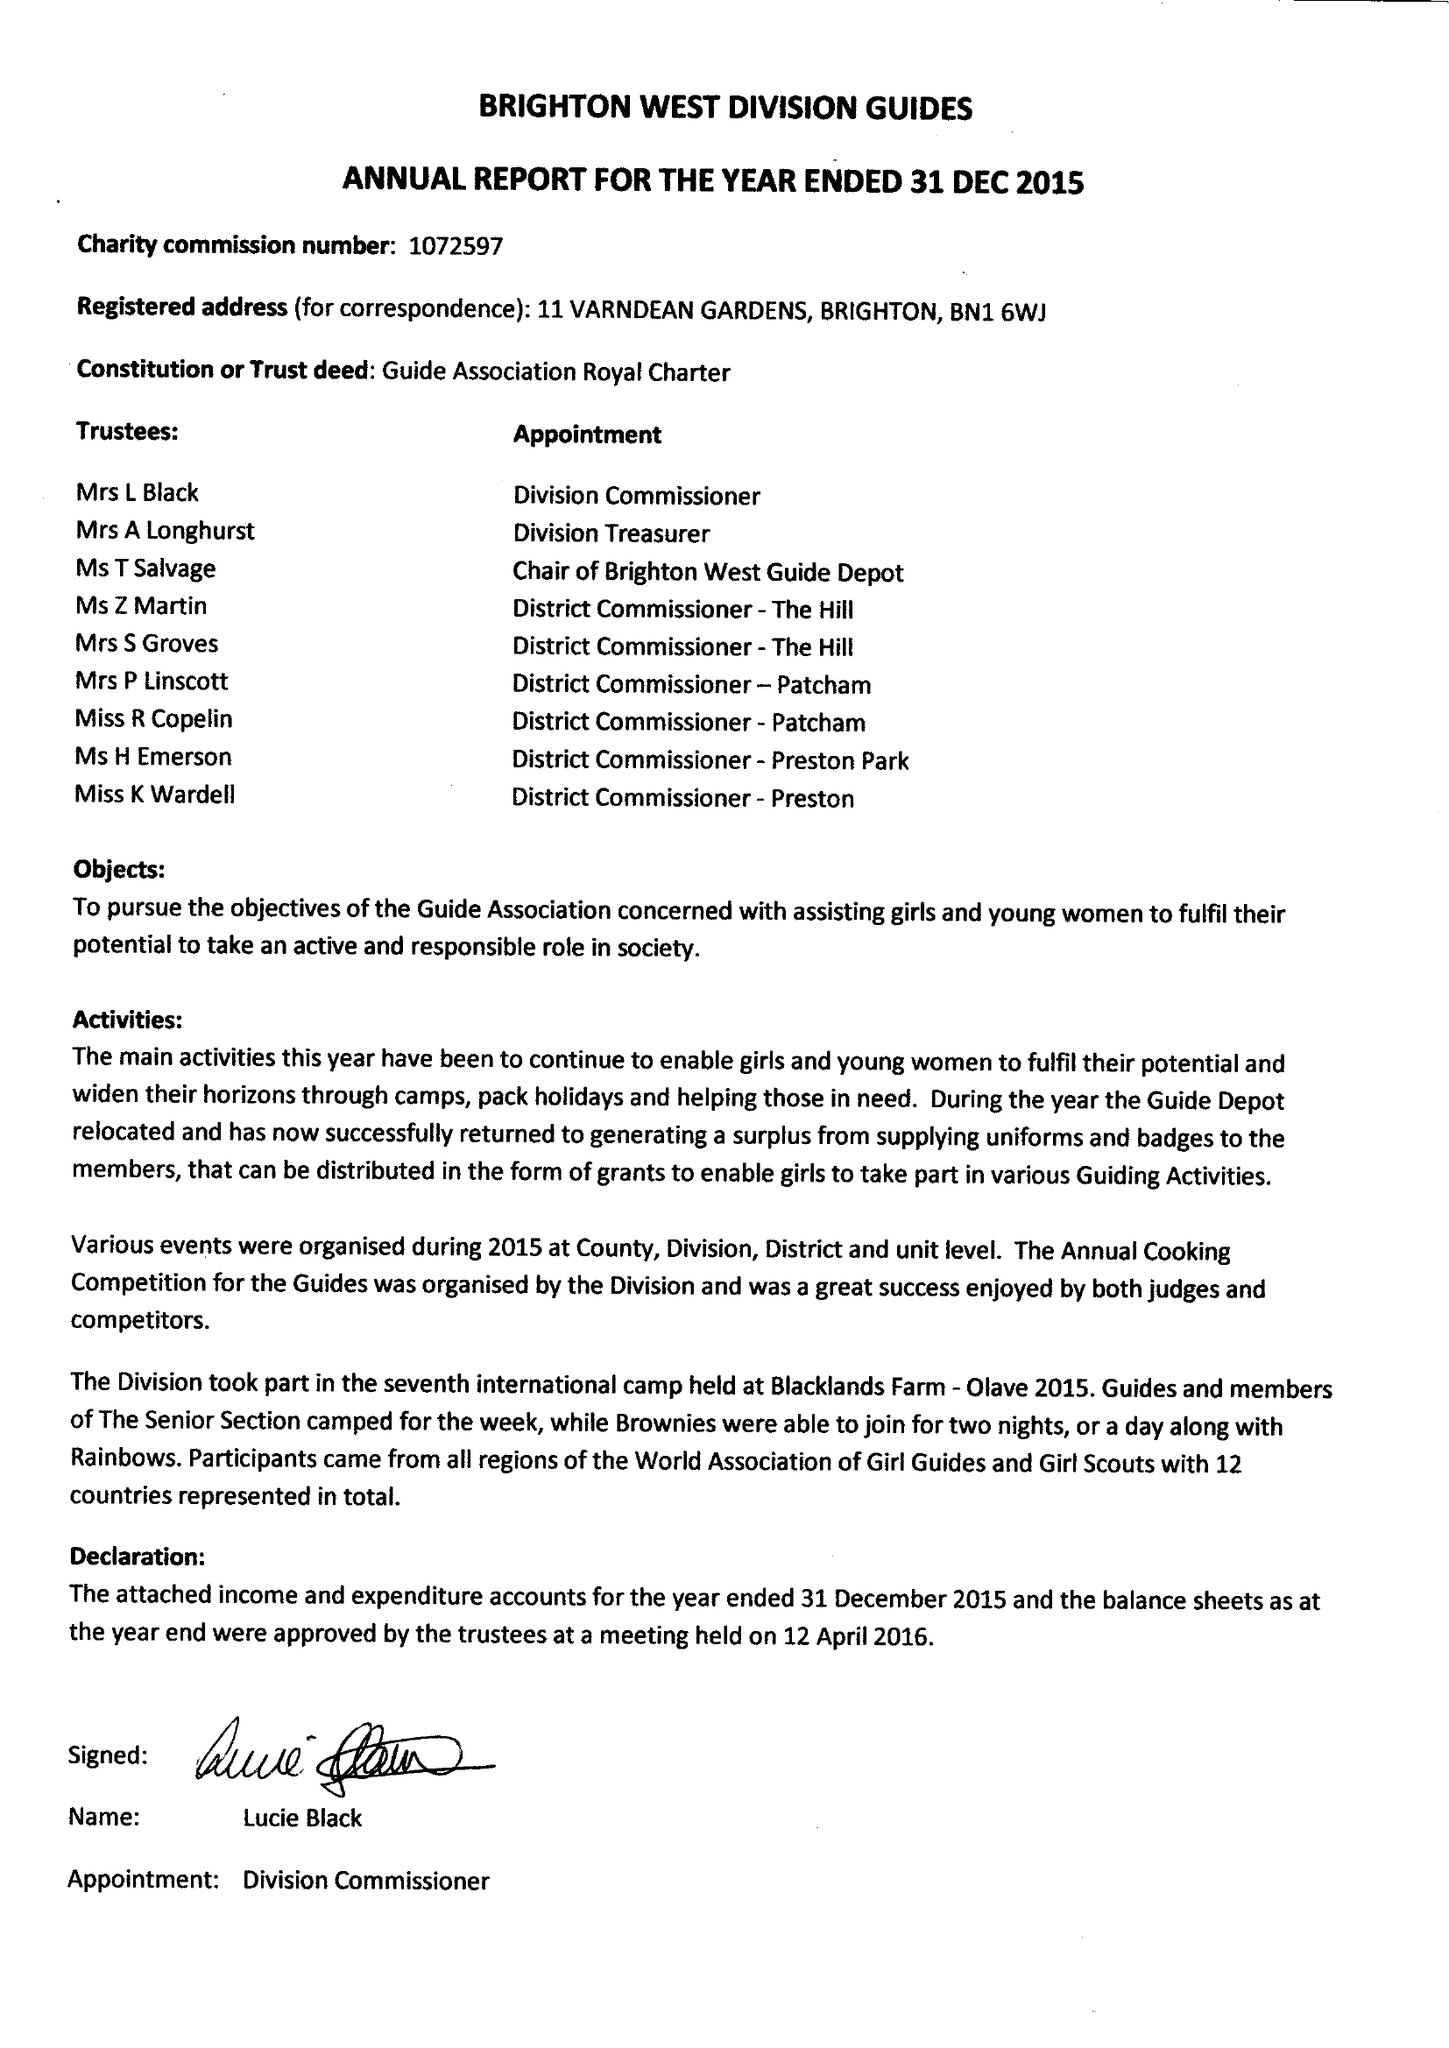What is the value for the charity_number?
Answer the question using a single word or phrase. 1072597 